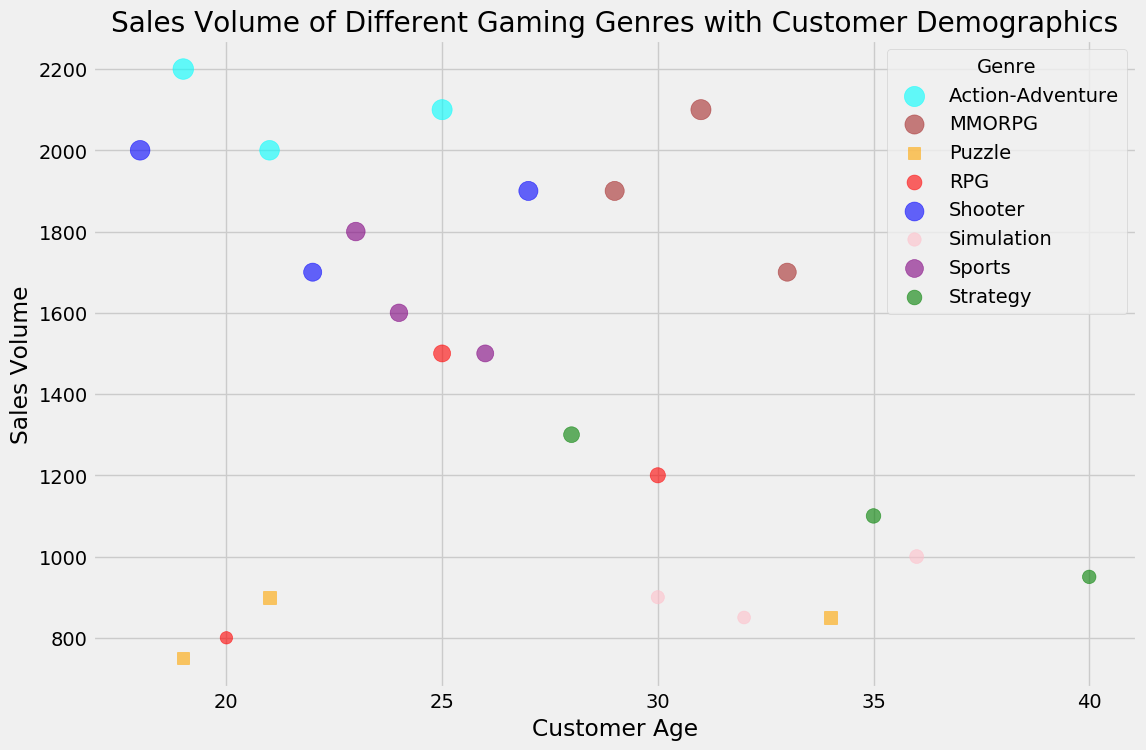What is the sales volume of RPG games in Los Angeles? The bubble representing RPG games played by females in Los Angeles is of medium size at an age of 30. According to the data, this size corresponds to a sales volume of 1200.
Answer: 1200 Which location has the highest sales volume for Shooter games? By comparing the sizes of the bubbles associated with Shooter games, the largest bubbles are for males aged 18 (Houston) and 27 (Philadelphia). The volume data indicates that these large bubbles represent volumes of 2000 and 1900, respectively, with Houston being the highest.
Answer: Houston Are there more female or male MMORPG players? Identify the markers corresponding to MMORPG (brown color) to see if they are circles (male) or squares (female). There are three male markers (San Francisco, Seattle, Indianapolis) and one female marker (Indianapolis), resulting in more male players.
Answer: Male Which genre is preferred by younger customers (under 25 years)? Find the bubble sizes and colors for genres with customer ages less than 25 years. Based on the plot, Shooter, Sports, Puzzle, and Action-Adventure genres have bubbles in this age range. Comparing the largest bubbles for these genres indicates Action-Adventure with a large presence.
Answer: Action-Adventure What is the difference in sales volume between males and females for the Strategy genre? The Strategy genre has bubbles for males (San Antonio, Dallas) and females (San Diego). The volumes are 1100, 1300 for males and 950 for females. Sum the male volumes (1100 + 1300 = 2400) and subtract the female volume (2400 - 950 = 1450).
Answer: 1450 Which age group has the highest average sales volume for RPG games? Identify the ages for RPG genre and the associated sales volumes: 25 (1500), 30 (1200), 20 (800). Calculate the average for each age and compare to find the highest: Age 25 has (1500), Age 30 has (1200), Age 20 has (800), making 25 the highest average.
Answer: Age 25 For Puzzle games, are the sales volumes higher in male or female demographics? Compare the sizes and volumes of bubbles for males (Columbus, 750) and females (Fort Worth, Charlotte, 900, 850). Sum volumes for males (750) and females (900 + 850 = 1750) and find that females have the higher sales volume.
Answer: Female Which gender shows a higher interest in Simulation games? Look for the markers corresponding to Simulation genre (pink color). More circles (males) or squares (females) will indicate the interest level. The data points show two males (Denver, Boston) and one female (Washington), indicating a higher interest in males.
Answer: Male 